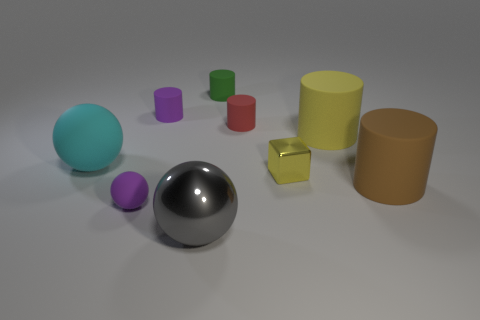Subtract 1 cylinders. How many cylinders are left? 4 Subtract all purple cylinders. How many cylinders are left? 4 Subtract all small red cylinders. How many cylinders are left? 4 Add 1 cyan matte things. How many objects exist? 10 Subtract all cyan cylinders. Subtract all red balls. How many cylinders are left? 5 Subtract all cubes. How many objects are left? 8 Subtract all red rubber objects. Subtract all red things. How many objects are left? 7 Add 6 tiny yellow cubes. How many tiny yellow cubes are left? 7 Add 9 small matte cubes. How many small matte cubes exist? 9 Subtract 1 yellow cylinders. How many objects are left? 8 